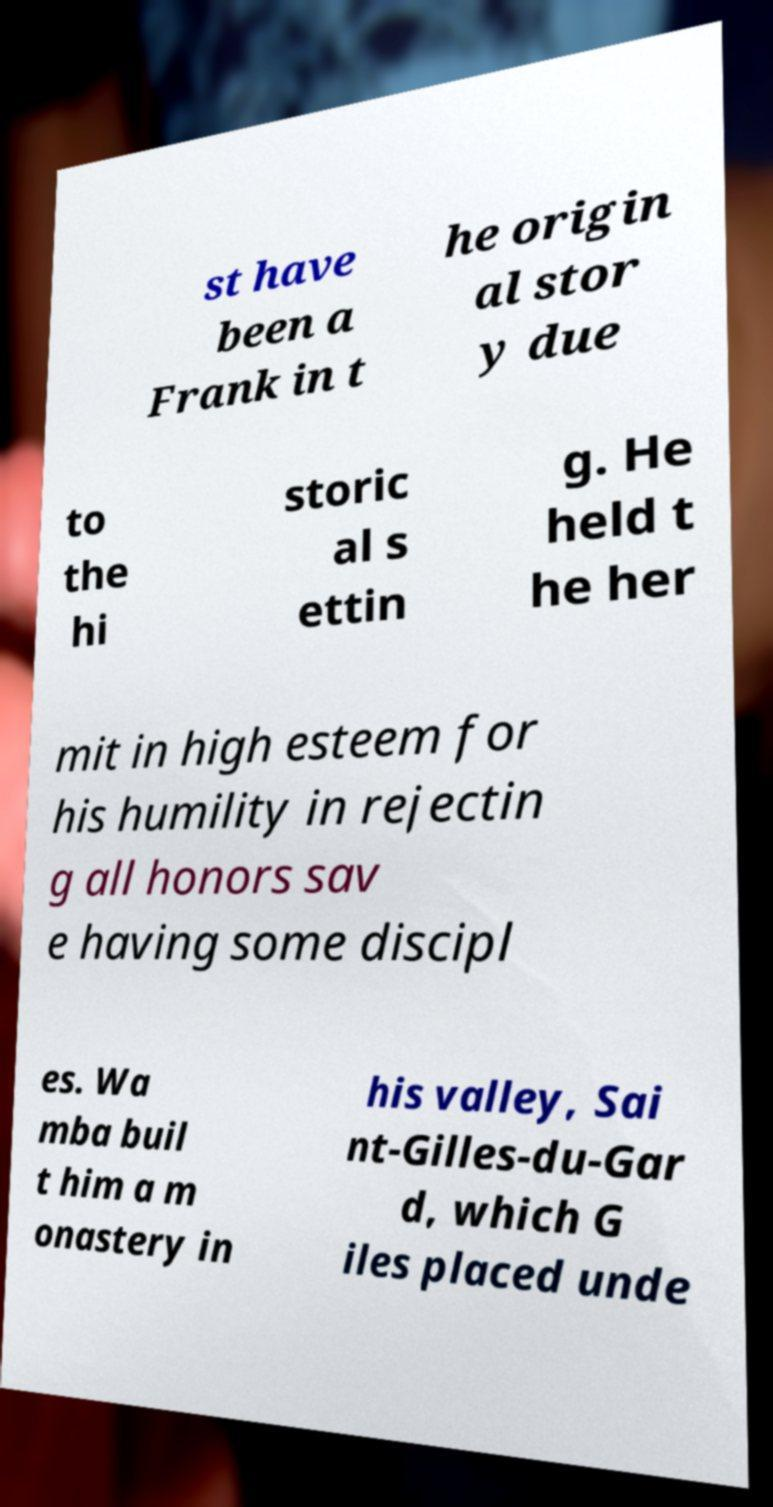Could you assist in decoding the text presented in this image and type it out clearly? st have been a Frank in t he origin al stor y due to the hi storic al s ettin g. He held t he her mit in high esteem for his humility in rejectin g all honors sav e having some discipl es. Wa mba buil t him a m onastery in his valley, Sai nt-Gilles-du-Gar d, which G iles placed unde 